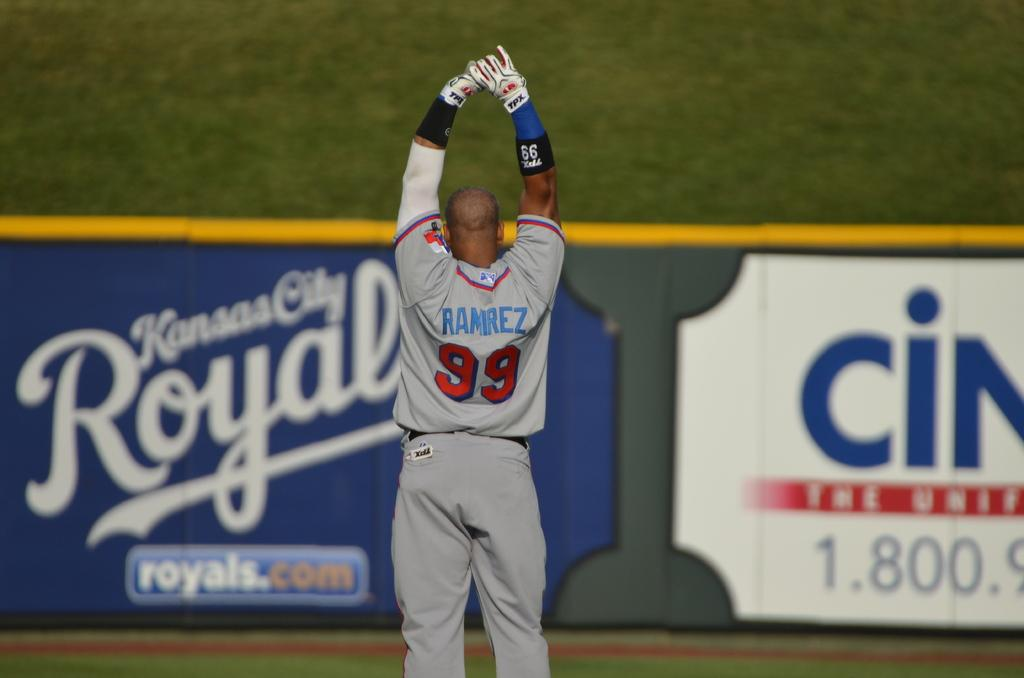Who or what is present in the image? There is a person in the image. What is the person wearing on their hands? The person is wearing gloves. What can be seen in the background of the image? There is an advertisement board in the background of the image. What type of surface is visible on the ground in the image? There is grass on the ground in the image. How does the person's mouth compare to the size of the advertisement board in the image? There is no information about the person's mouth size in the image, so it cannot be compared to the size of the advertisement board. 